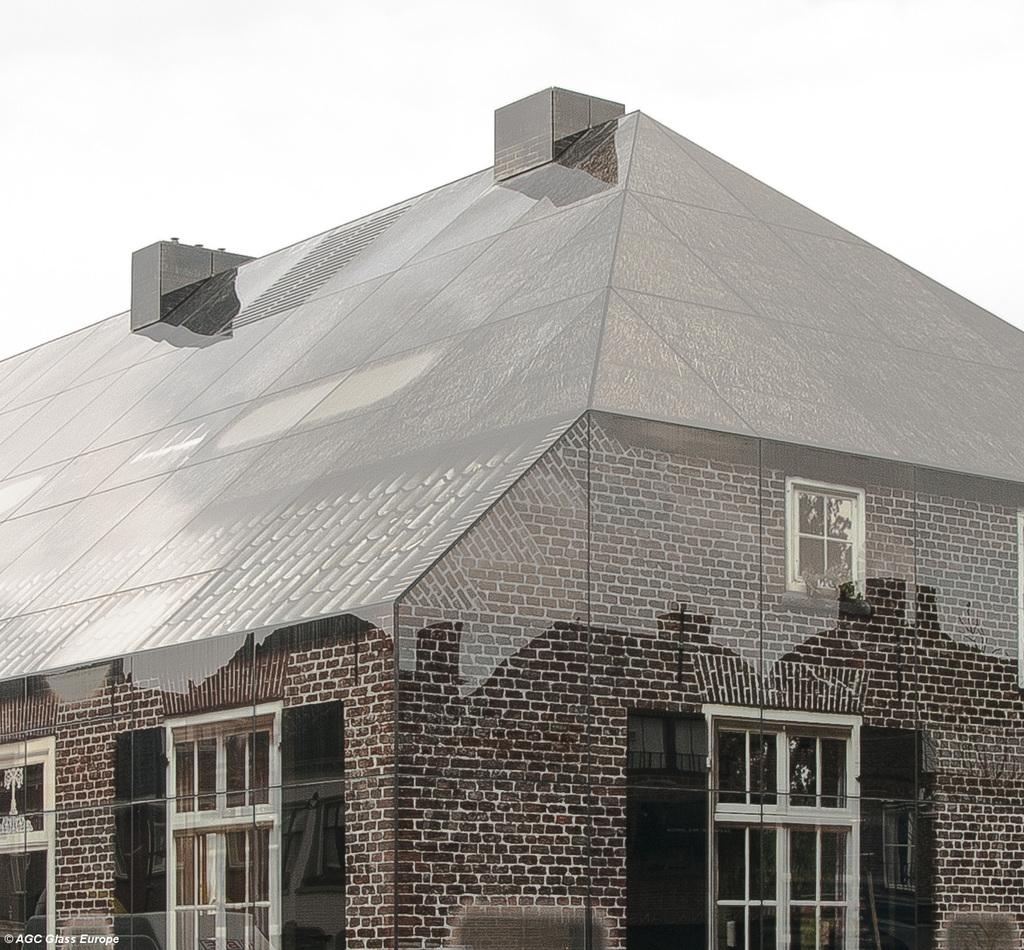What is the main structure in the front of the image? There is a building in the front of the image. How would you describe the sky in the image? The sky is cloudy in the image. Is there any text visible in the image? Yes, there is some text visible at the bottom left of the image. Can you see your dad kicking a ball in the image? There is no person, let alone a dad, kicking a ball in the image. What type of yarn is being used to create the clouds in the image? The image does not depict clouds being created with yarn; the clouds are a natural part of the sky. 